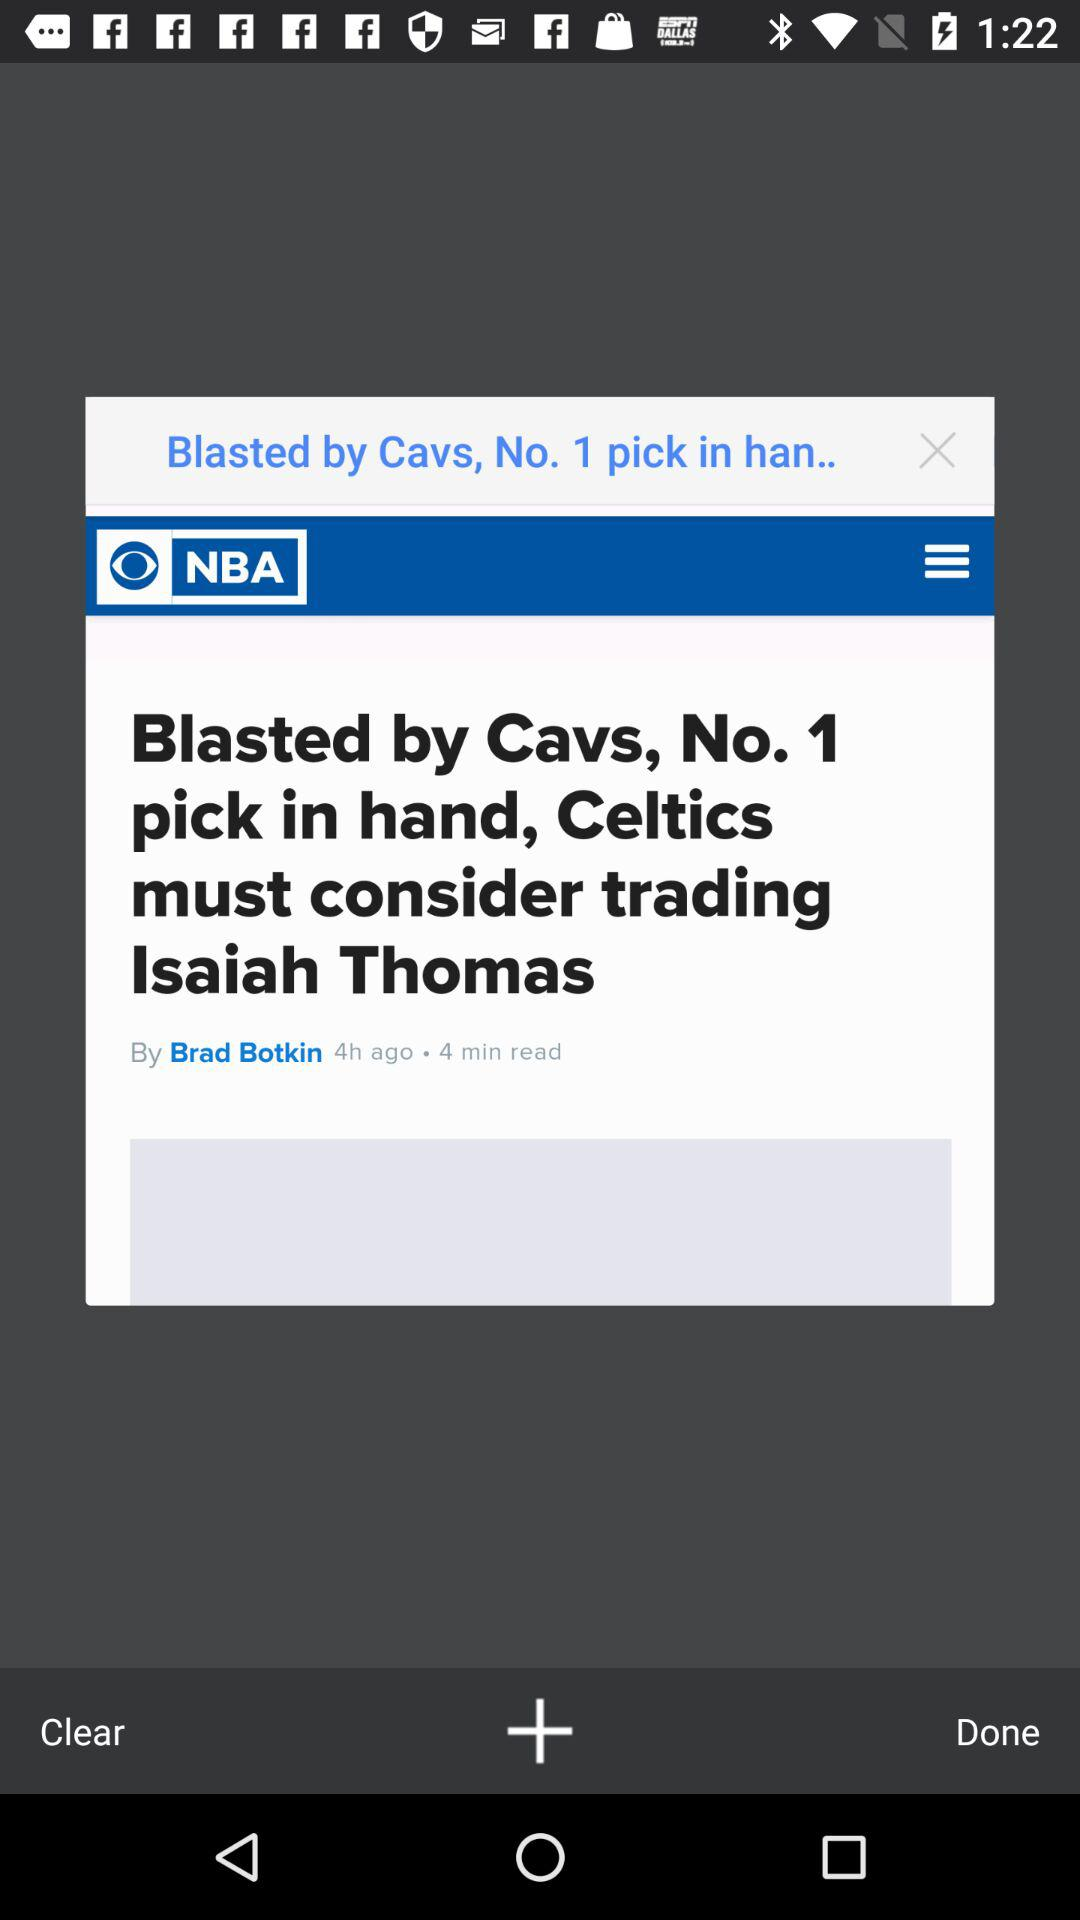Who's the author of the news? The author of the news is Brad Botkin. 